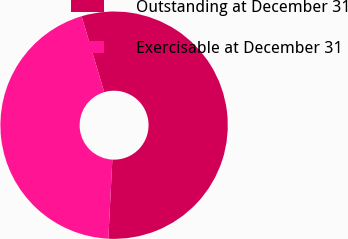Convert chart. <chart><loc_0><loc_0><loc_500><loc_500><pie_chart><fcel>Outstanding at December 31<fcel>Exercisable at December 31<nl><fcel>55.42%<fcel>44.58%<nl></chart> 